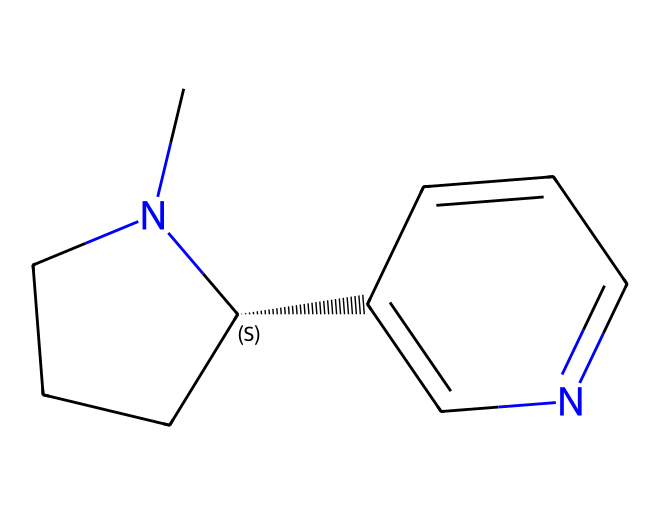What is the molecular formula of nicotine? To find the molecular formula, count the number of each type of atom present in the SMILES representation. The structure CN1CCC[C@H]1C2=CN=CC=C2 indicates there are 10 carbon (C) atoms, 14 hydrogen (H) atoms, and 2 nitrogen (N) atoms, leading to the formula C10H14N2.
Answer: C10H14N2 How many nitrogen atoms are present in nicotine? By examining the SMILES representation, we identify the presence of two nitrogen (N) atoms in the structure, confirmed by the "N" characters in the SMILES.
Answer: 2 What type of compound is nicotine classified as? Nicotine is categorized as an alkaloid due to the presence of nitrogen atoms in its structure and its physiological effects. Alkaloids typically have basic structures with nitrogen and are well-known for their effects on living organisms.
Answer: alkaloid What is the total number of rings in the structure of nicotine? Observing the SMILES representation, we can see the "N1" and "C2" designations indicating two ring structures. Counting these shows there are two rings present, making the total number of rings two.
Answer: 2 Which part of this chemical structure is associated with addictive properties? The presence of the nitrogen atoms in an alkaloid structure indicates potential for neurotransmitter interaction, specifically by mimicking acetylcholine. This mimicking property plays a critical role in nicotine's addictive nature.
Answer: nitrogen What is the stereochemistry designation of the chiral center in nicotine? The "C@H" in the SMILES indicates a chiral center at this carbon atom. Chiral centers can exist in two different configurations, but the notation "@H" indicates that this specific carbon is indeed chiral. This is significant for the biological activity of nicotine.
Answer: chiral 